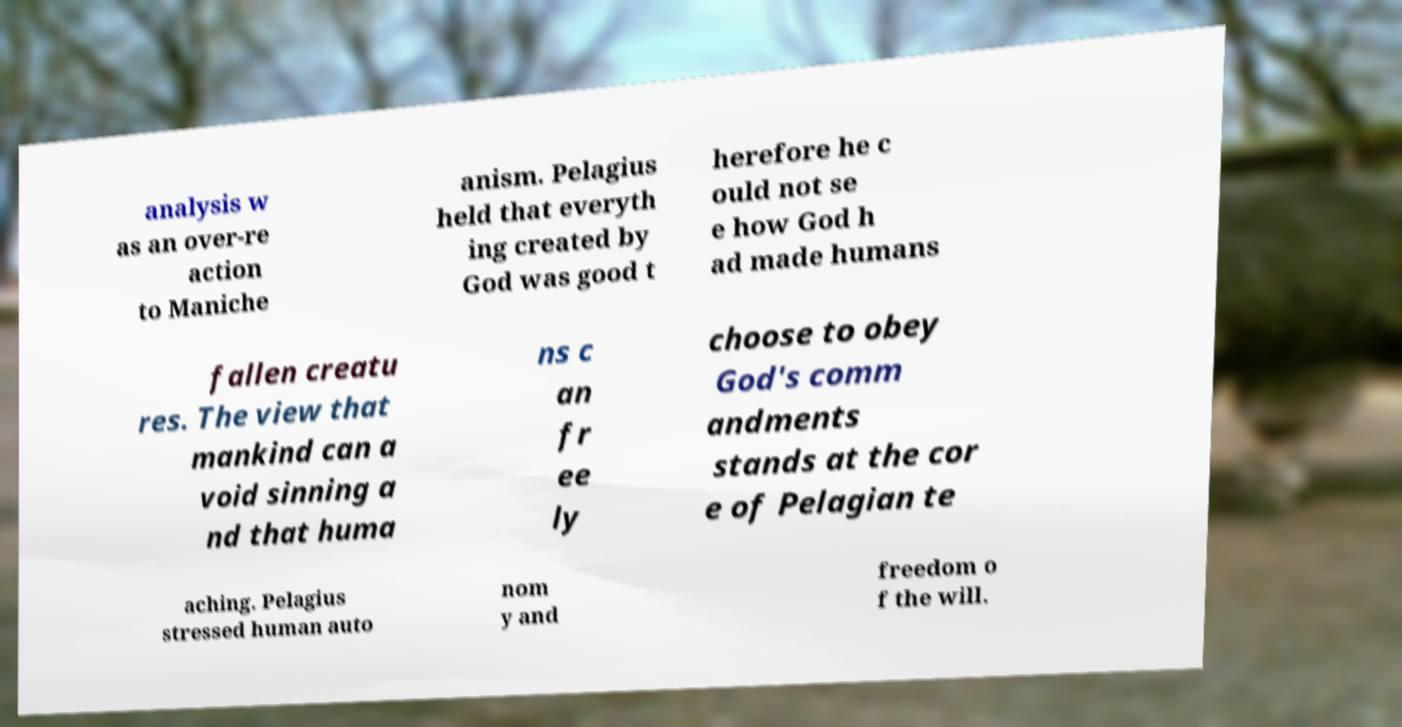Could you assist in decoding the text presented in this image and type it out clearly? analysis w as an over-re action to Maniche anism. Pelagius held that everyth ing created by God was good t herefore he c ould not se e how God h ad made humans fallen creatu res. The view that mankind can a void sinning a nd that huma ns c an fr ee ly choose to obey God's comm andments stands at the cor e of Pelagian te aching. Pelagius stressed human auto nom y and freedom o f the will. 